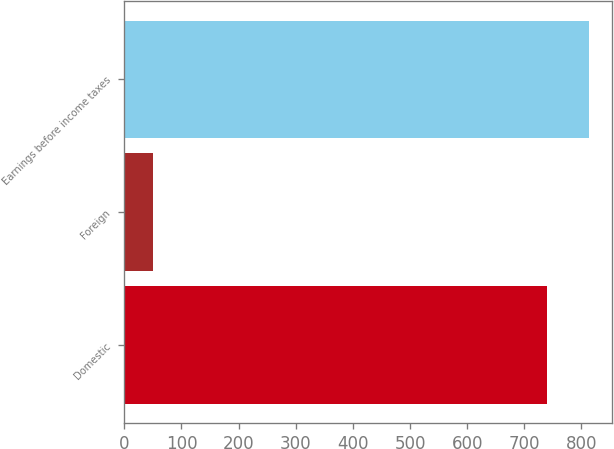Convert chart to OTSL. <chart><loc_0><loc_0><loc_500><loc_500><bar_chart><fcel>Domestic<fcel>Foreign<fcel>Earnings before income taxes<nl><fcel>739.4<fcel>50.3<fcel>813.34<nl></chart> 